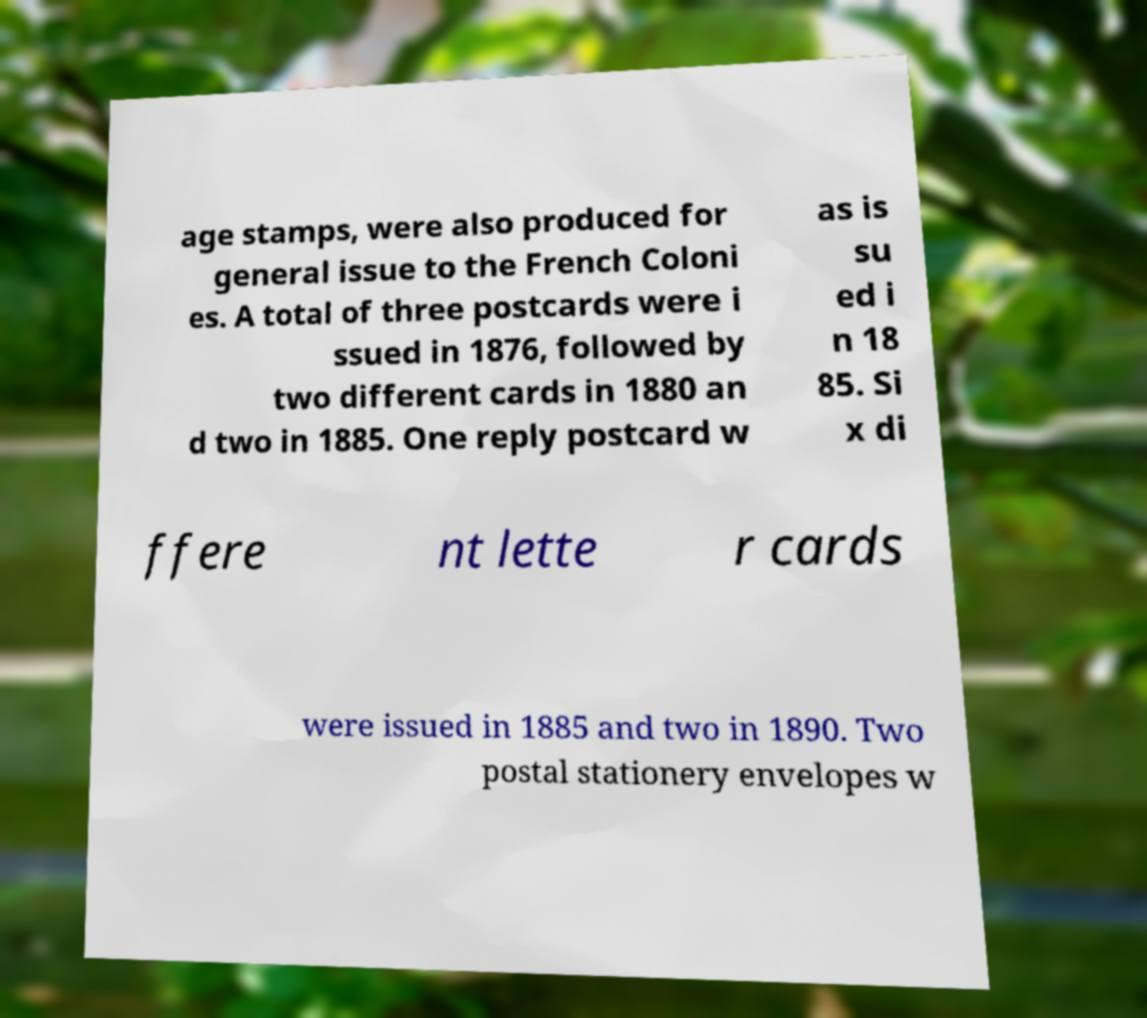Please identify and transcribe the text found in this image. age stamps, were also produced for general issue to the French Coloni es. A total of three postcards were i ssued in 1876, followed by two different cards in 1880 an d two in 1885. One reply postcard w as is su ed i n 18 85. Si x di ffere nt lette r cards were issued in 1885 and two in 1890. Two postal stationery envelopes w 